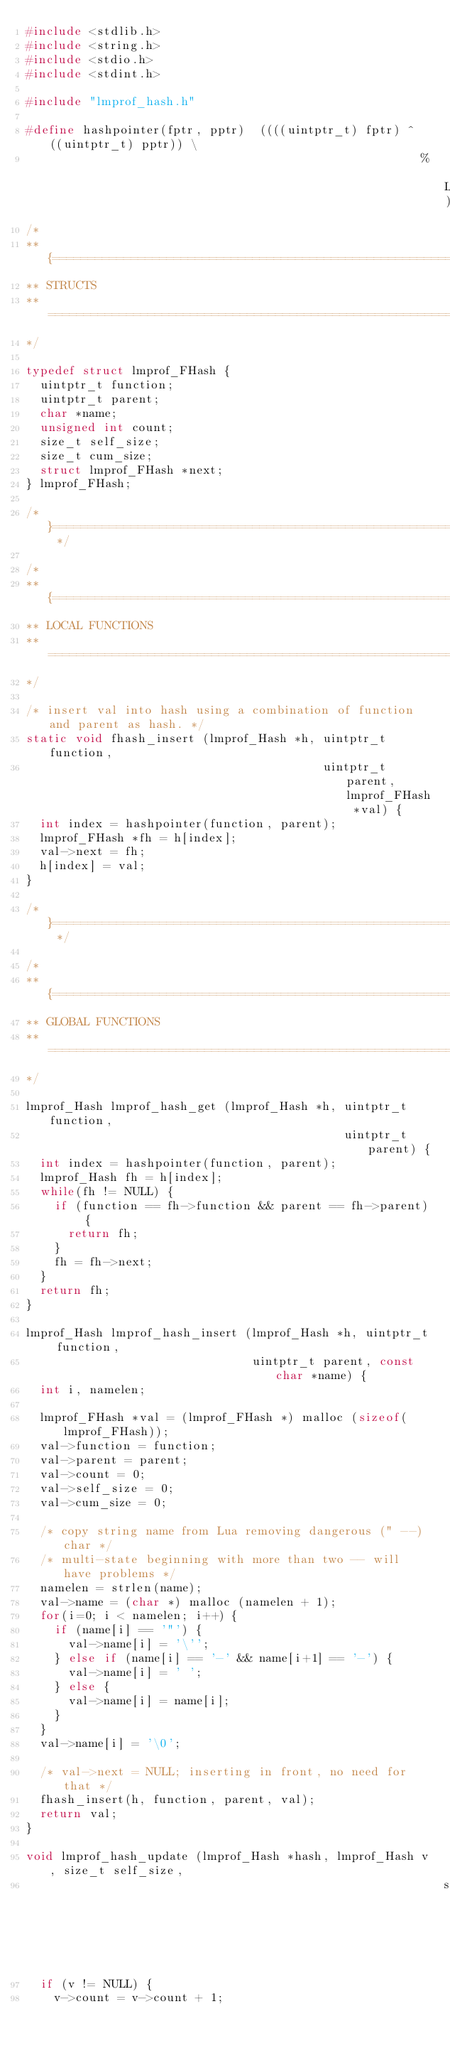<code> <loc_0><loc_0><loc_500><loc_500><_C_>#include <stdlib.h>
#include <string.h>
#include <stdio.h>
#include <stdint.h>

#include "lmprof_hash.h"

#define hashpointer(fptr, pptr)  ((((uintptr_t) fptr) ^ ((uintptr_t) pptr)) \
                                                        % LMPROF_HASH_SIZE)
/*
** {==================================================================
** STRUCTS
** ===================================================================
*/

typedef struct lmprof_FHash {
  uintptr_t function;
  uintptr_t parent;
  char *name;
  unsigned int count;
  size_t self_size;
  size_t cum_size;
  struct lmprof_FHash *next;
} lmprof_FHash;

/* }================================================================== */

/*
** {==================================================================
** LOCAL FUNCTIONS
** ===================================================================
*/

/* insert val into hash using a combination of function and parent as hash. */
static void fhash_insert (lmprof_Hash *h, uintptr_t function,
                                          uintptr_t parent, lmprof_FHash *val) {
  int index = hashpointer(function, parent);
  lmprof_FHash *fh = h[index];
  val->next = fh;
  h[index] = val;
}

/* }================================================================== */

/*
** {==================================================================
** GLOBAL FUNCTIONS
** ===================================================================
*/

lmprof_Hash lmprof_hash_get (lmprof_Hash *h, uintptr_t function,
                                             uintptr_t parent) {
  int index = hashpointer(function, parent);
  lmprof_Hash fh = h[index];
  while(fh != NULL) {
    if (function == fh->function && parent == fh->parent) {
      return fh;
    }
    fh = fh->next;
  }
  return fh;
}

lmprof_Hash lmprof_hash_insert (lmprof_Hash *h, uintptr_t function,
                                uintptr_t parent, const char *name) {
  int i, namelen;

  lmprof_FHash *val = (lmprof_FHash *) malloc (sizeof(lmprof_FHash));
  val->function = function;
  val->parent = parent;
  val->count = 0;
  val->self_size = 0;
  val->cum_size = 0;

  /* copy string name from Lua removing dangerous (" --) char */
  /* multi-state beginning with more than two -- will have problems */
  namelen = strlen(name);
  val->name = (char *) malloc (namelen + 1);
  for(i=0; i < namelen; i++) {
    if (name[i] == '"') {
      val->name[i] = '\'';
    } else if (name[i] == '-' && name[i+1] == '-') {
      val->name[i] = ' ';
    } else {
      val->name[i] = name[i];
    }
  }
  val->name[i] = '\0';

  /* val->next = NULL; inserting in front, no need for that */
  fhash_insert(h, function, parent, val);
  return val;
}

void lmprof_hash_update (lmprof_Hash *hash, lmprof_Hash v, size_t self_size,
                                                           size_t cum_size) {
  if (v != NULL) {
    v->count = v->count + 1;</code> 